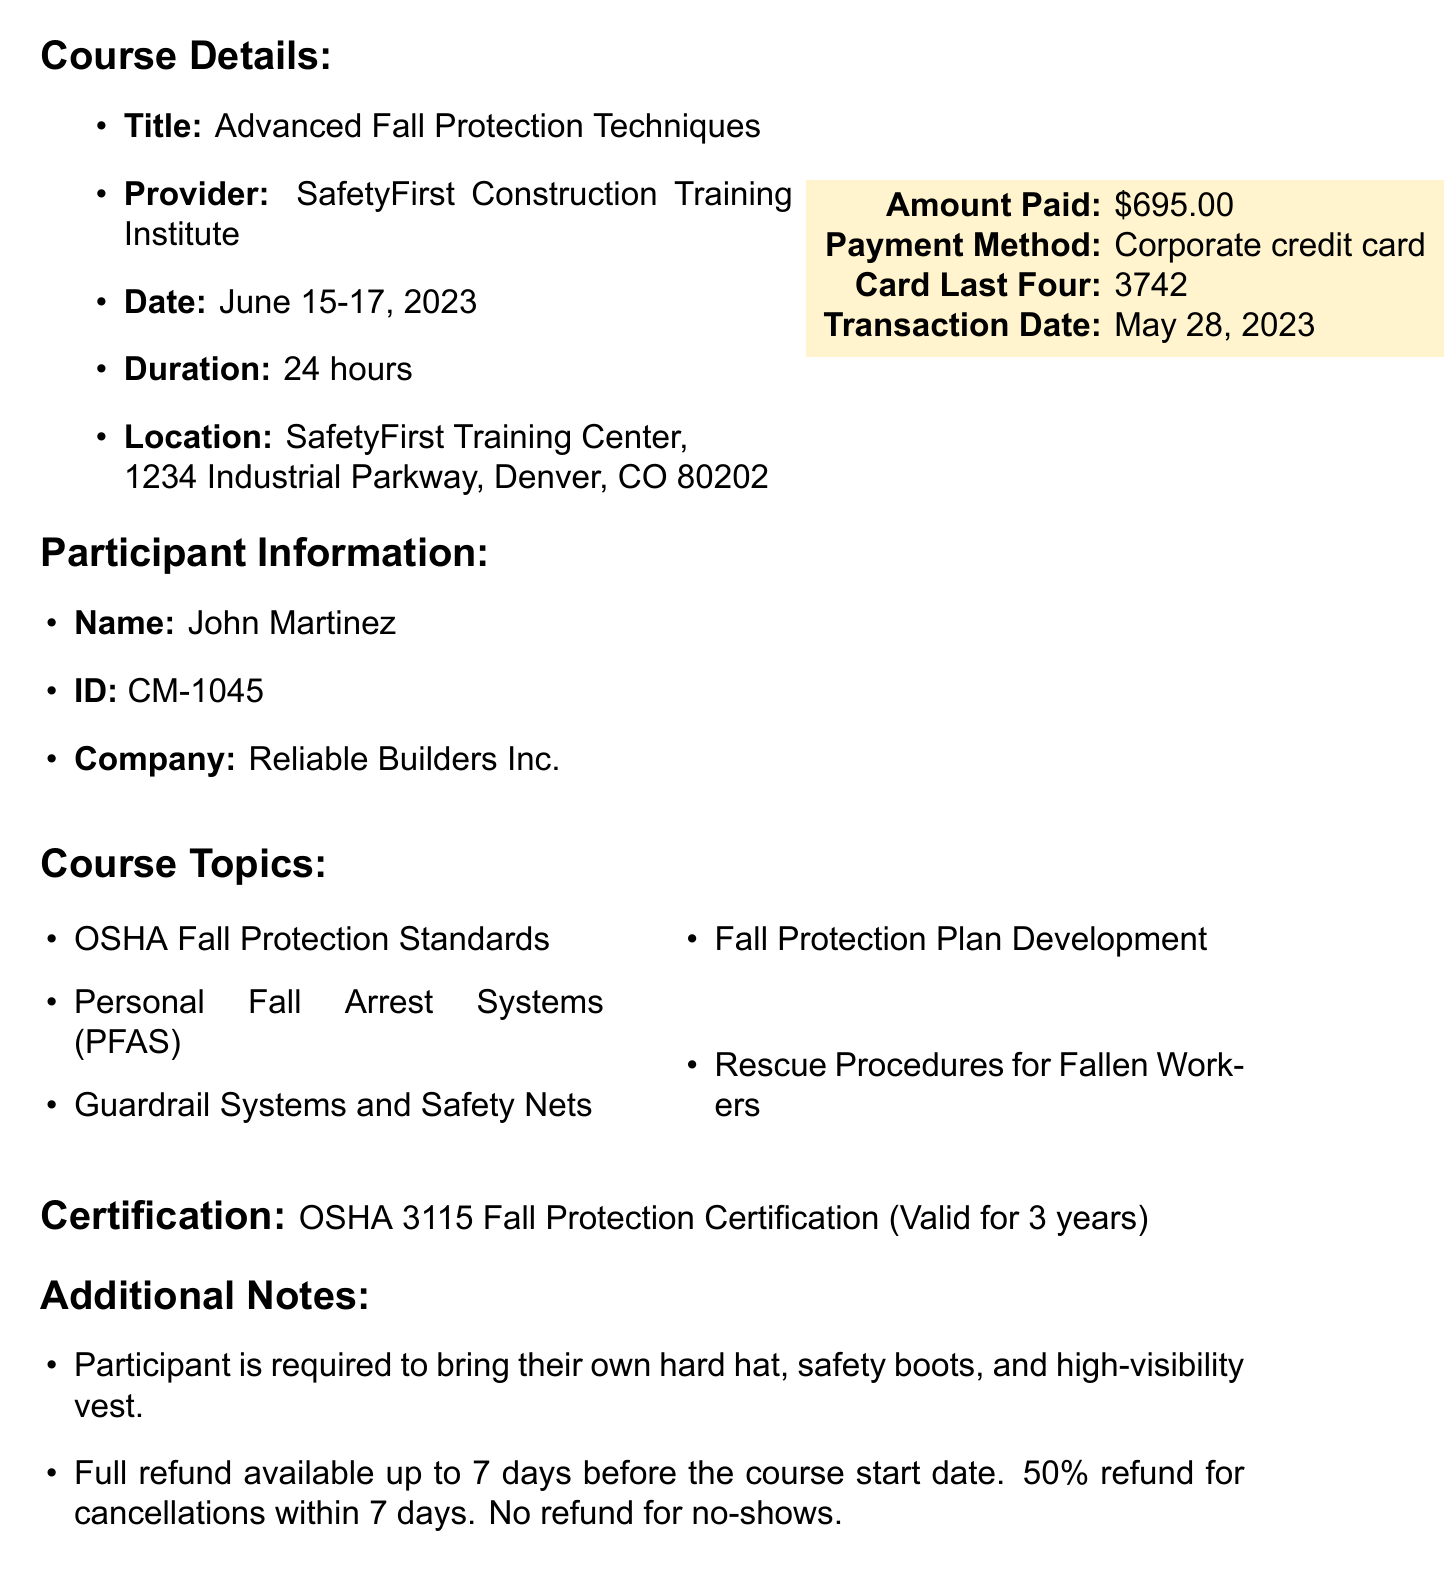What is the receipt number? The receipt number is displayed prominently at the top of the document, indicating its unique identifier.
Answer: FP-2023-0587 Who is the training provider? The training provider's name is listed under the course details, showing who is conducting the training.
Answer: SafetyFirst Construction Training Institute What is the duration of the training course? The duration is given as part of the course details, specifying how long the training will last.
Answer: 24 hours What is the total amount paid? The amount paid is clearly laid out in the financial section of the receipt, indicating the cost of the course.
Answer: $695.00 What is the validity period of the certification? The validity period is mentioned after the certification information, indicating how long the certification is valid.
Answer: 3 years What should the participant bring to the training? Additional notes specify the items required for participation in the training course.
Answer: Hard hat, safety boots, and high-visibility vest Who authorized the payment? The individual responsible for authorizing the payment is mentioned near the end of the document.
Answer: Sarah Johnson What happens if the participant cancels within 7 days? The refund policy outlines the consequences of canceling within a week of the course start date.
Answer: 50% refund Where is the training location? The training location is provided in the course details section, indicating where the training will be held.
Answer: SafetyFirst Training Center, 1234 Industrial Parkway, Denver, CO 80202 